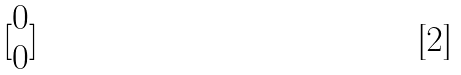Convert formula to latex. <formula><loc_0><loc_0><loc_500><loc_500>[ \begin{matrix} 0 \\ 0 \end{matrix} ]</formula> 